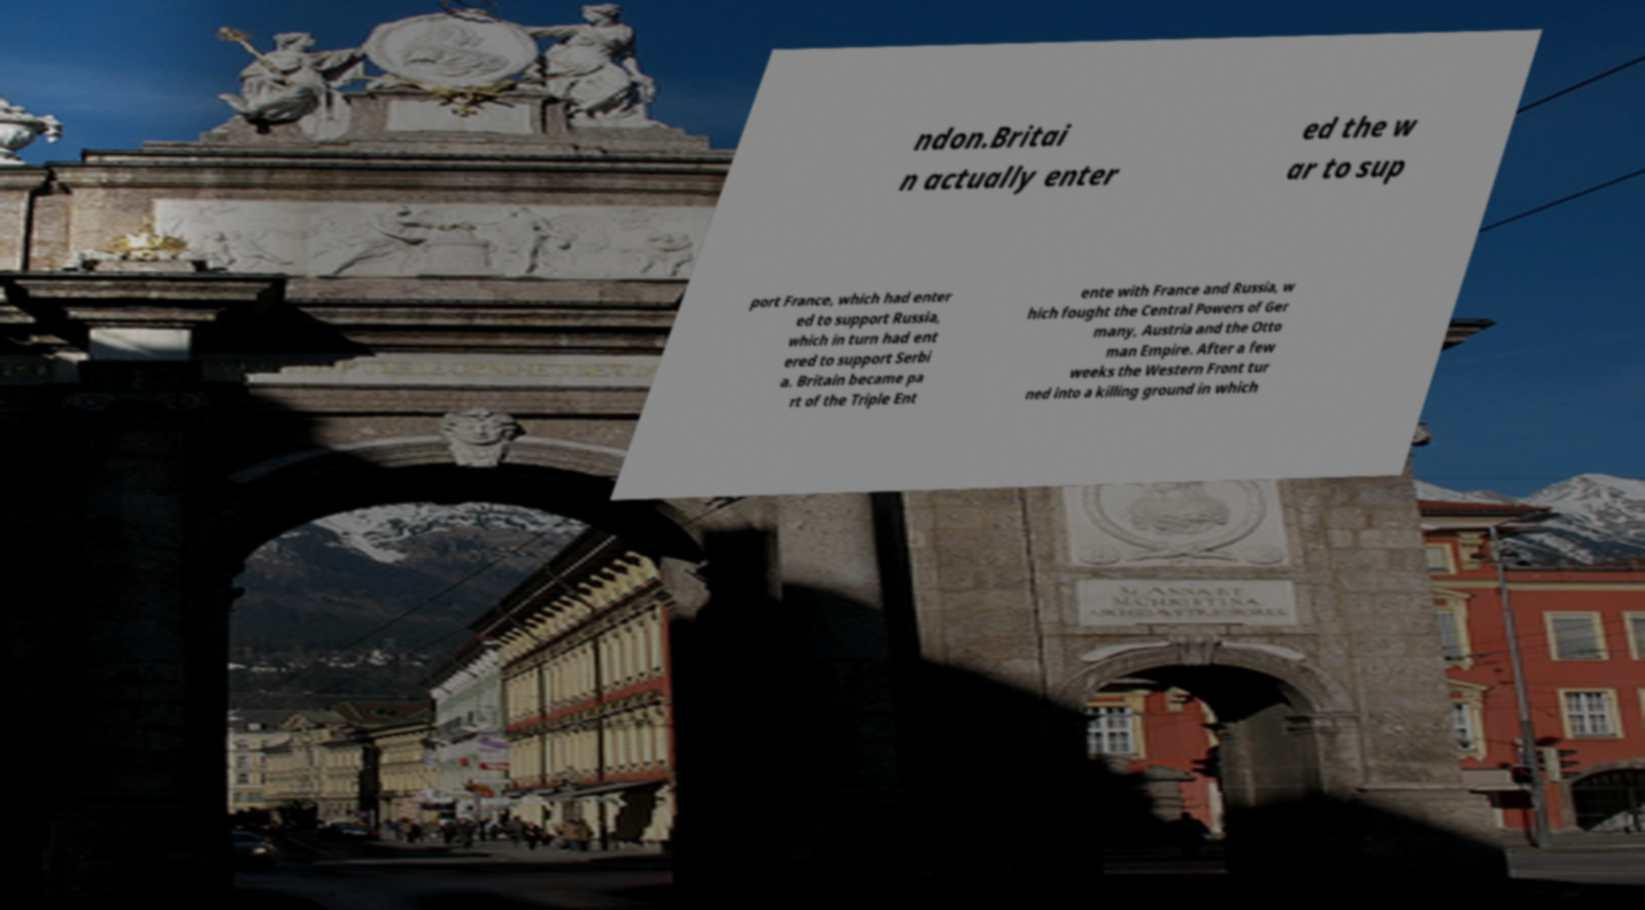Could you extract and type out the text from this image? ndon.Britai n actually enter ed the w ar to sup port France, which had enter ed to support Russia, which in turn had ent ered to support Serbi a. Britain became pa rt of the Triple Ent ente with France and Russia, w hich fought the Central Powers of Ger many, Austria and the Otto man Empire. After a few weeks the Western Front tur ned into a killing ground in which 